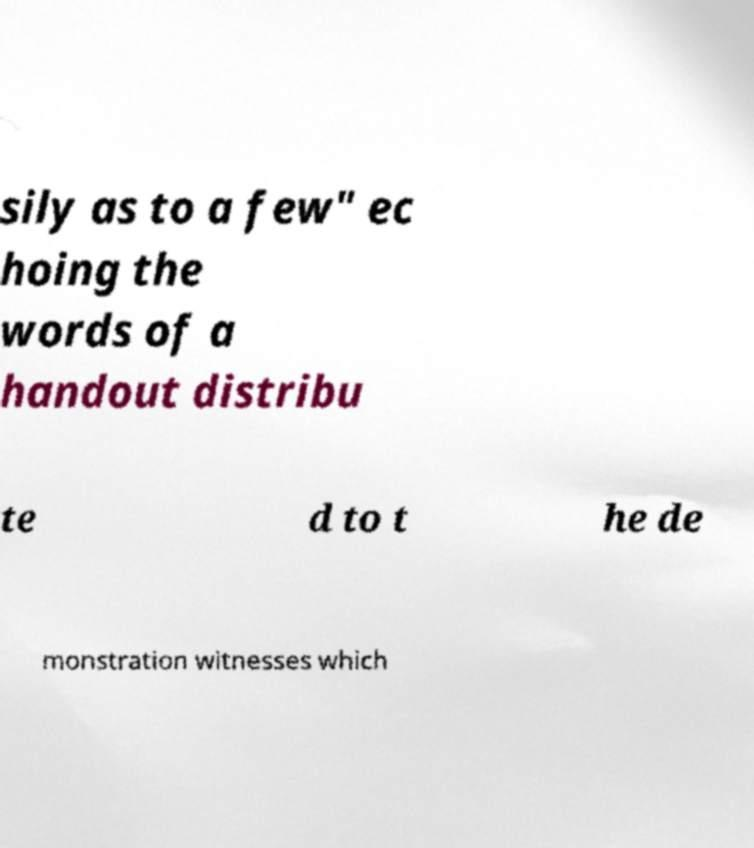For documentation purposes, I need the text within this image transcribed. Could you provide that? sily as to a few" ec hoing the words of a handout distribu te d to t he de monstration witnesses which 